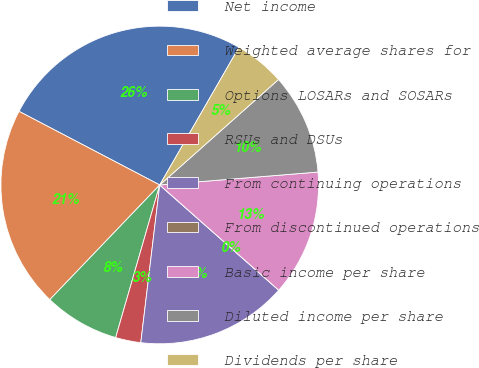Convert chart to OTSL. <chart><loc_0><loc_0><loc_500><loc_500><pie_chart><fcel>Net income<fcel>Weighted average shares for<fcel>Options LOSARs and SOSARs<fcel>RSUs and DSUs<fcel>From continuing operations<fcel>From discontinued operations<fcel>Basic income per share<fcel>Diluted income per share<fcel>Dividends per share<nl><fcel>25.64%<fcel>20.51%<fcel>7.69%<fcel>2.57%<fcel>15.38%<fcel>0.0%<fcel>12.82%<fcel>10.26%<fcel>5.13%<nl></chart> 